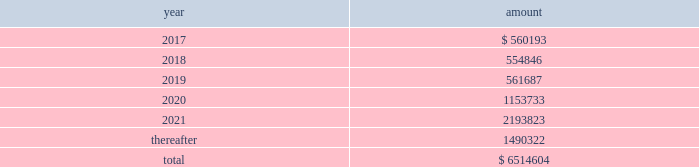New term loan a facility , with the remaining unpaid principal amount of loans under the new term loan a facility due and payable in full at maturity on june 6 , 2021 .
Principal amounts outstanding under the new revolving loan facility are due and payable in full at maturity on june 6 , 2021 , subject to earlier repayment pursuant to the springing maturity date described above .
In addition to paying interest on outstanding principal under the borrowings , we are obligated to pay a quarterly commitment fee at a rate determined by reference to a total leverage ratio , with a maximum commitment fee of 40% ( 40 % ) of the applicable margin for eurocurrency loans .
In july 2016 , breakaway four , ltd. , as borrower , and nclc , as guarantor , entered into a supplemental agreement , which amended the breakaway four loan to , among other things , increase the aggregate principal amount of commitments under the multi-draw term loan credit facility from 20ac590.5 million to 20ac729.9 million .
In june 2016 , we took delivery of seven seas explorer .
To finance the payment due upon delivery , we had export credit financing in place for 80% ( 80 % ) of the contract price .
The associated $ 373.6 million term loan bears interest at 3.43% ( 3.43 % ) with a maturity date of june 30 , 2028 .
Principal and interest payments shall be paid semiannually .
In december 2016 , nclc issued $ 700.0 million aggregate principal amount of 4.750% ( 4.750 % ) senior unsecured notes due december 2021 ( the 201cnotes 201d ) in a private offering ( the 201coffering 201d ) at par .
Nclc used the net proceeds from the offering , after deducting the initial purchasers 2019 discount and estimated fees and expenses , together with cash on hand , to purchase its outstanding 5.25% ( 5.25 % ) senior notes due 2019 having an aggregate outstanding principal amount of $ 680 million .
The redemption of the 5.25% ( 5.25 % ) senior notes due 2019 was completed in january 2017 .
Nclc will pay interest on the notes at 4.750% ( 4.750 % ) per annum , semiannually on june 15 and december 15 of each year , commencing on june 15 , 2017 , to holders of record at the close of business on the immediately preceding june 1 and december 1 , respectively .
Nclc may redeem the notes , in whole or part , at any time prior to december 15 , 2018 , at a price equal to 100% ( 100 % ) of the principal amount of the notes redeemed plus accrued and unpaid interest to , but not including , the redemption date and a 201cmake-whole premium . 201d nclc may redeem the notes , in whole or in part , on or after december 15 , 2018 , at the redemption prices set forth in the indenture governing the notes .
At any time ( which may be more than once ) on or prior to december 15 , 2018 , nclc may choose to redeem up to 40% ( 40 % ) of the aggregate principal amount of the notes at a redemption price equal to 104.750% ( 104.750 % ) of the face amount thereof with an amount equal to the net proceeds of one or more equity offerings , so long as at least 60% ( 60 % ) of the aggregate principal amount of the notes issued remains outstanding following such redemption .
The indenture governing the notes contains covenants that limit nclc 2019s ability ( and its restricted subsidiaries 2019 ability ) to , among other things : ( i ) incur or guarantee additional indebtedness or issue certain preferred shares ; ( ii ) pay dividends and make certain other restricted payments ; ( iii ) create restrictions on the payment of dividends or other distributions to nclc from its restricted subsidiaries ; ( iv ) create liens on certain assets to secure debt ; ( v ) make certain investments ; ( vi ) engage in transactions with affiliates ; ( vii ) engage in sales of assets and subsidiary stock ; and ( viii ) transfer all or substantially all of its assets or enter into merger or consolidation transactions .
The indenture governing the notes also provides for events of default , which , if any of them occurs , would permit or require the principal , premium ( if any ) , interest and other monetary obligations on all of the then-outstanding notes to become due and payable immediately .
Interest expense , net for the year ended december 31 , 2016 was $ 276.9 million which included $ 34.7 million of amortization of deferred financing fees and a $ 27.7 million loss on extinguishment of debt .
Interest expense , net for the year ended december 31 , 2015 was $ 221.9 million which included $ 36.7 million of amortization of deferred financing fees and a $ 12.7 million loss on extinguishment of debt .
Interest expense , net for the year ended december 31 , 2014 was $ 151.8 million which included $ 32.3 million of amortization of deferred financing fees and $ 15.4 million of expenses related to financing transactions in connection with the acquisition of prestige .
Certain of our debt agreements contain covenants that , among other things , require us to maintain a minimum level of liquidity , as well as limit our net funded debt-to-capital ratio , maintain certain other ratios and restrict our ability to pay dividends .
Substantially all of our ships and other property and equipment are pledged as collateral for certain of our debt .
We believe we were in compliance with these covenants as of december 31 , 2016 .
The following are scheduled principal repayments on long-term debt including capital lease obligations as of december 31 , 2016 for each of the next five years ( in thousands ) : .
We had an accrued interest liability of $ 32.5 million and $ 34.2 million as of december 31 , 2016 and 2015 , respectively. .
What is the percentage change in interest expense-net , from 2015 to 2016? 
Computations: ((276.9 - 221.9) / 221.9)
Answer: 0.24786. 